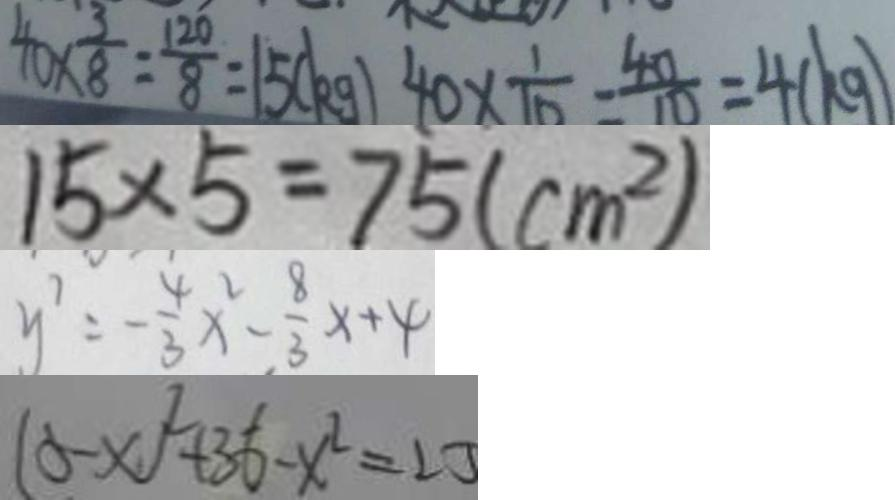<formula> <loc_0><loc_0><loc_500><loc_500>4 0 \times \frac { 3 } { 8 } = \frac { 1 2 0 } { 8 } = 1 5 ( k g ) 4 0 \times \frac { 1 } { 1 0 } = \frac { 4 0 } { 1 0 } = 4 ( k g ) 
 1 5 \times 5 = 7 5 ( c m ^ { 2 } ) 
 y ^ { 7 } = - \frac { 4 } { 3 } x ^ { 2 } - \frac { 8 } { 3 } x + 4 
 ( 5 - x ) ^ { 2 } + 3 6 - x ^ { 2 } = 2 3</formula> 